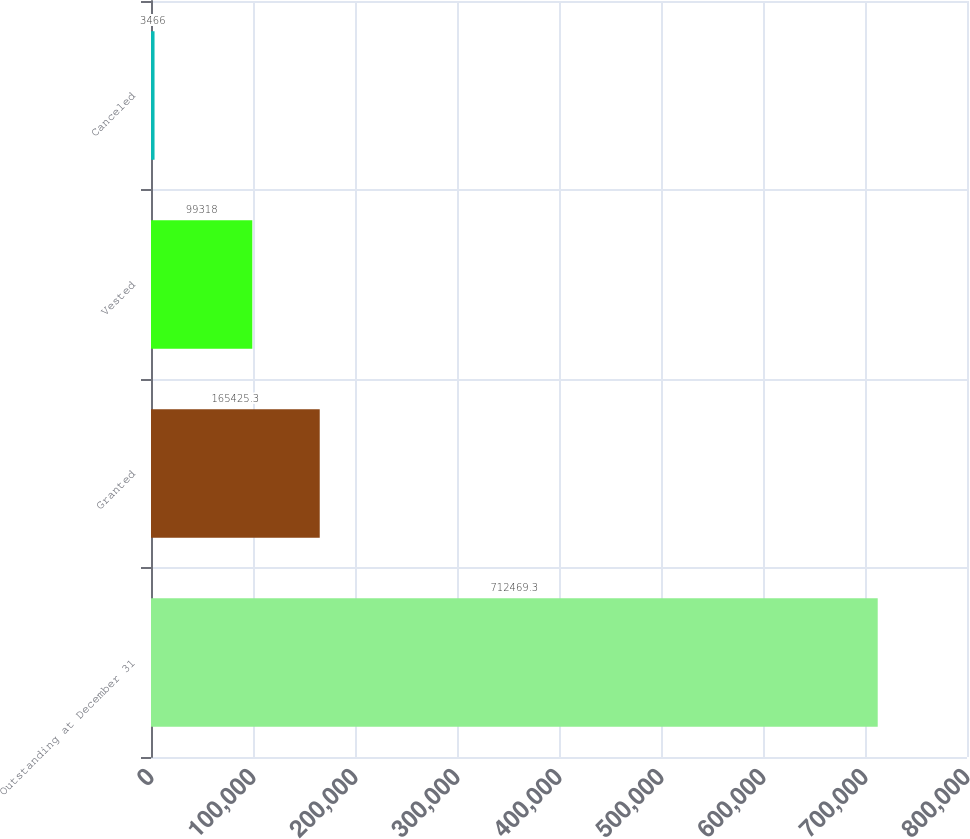Convert chart to OTSL. <chart><loc_0><loc_0><loc_500><loc_500><bar_chart><fcel>Outstanding at December 31<fcel>Granted<fcel>Vested<fcel>Canceled<nl><fcel>712469<fcel>165425<fcel>99318<fcel>3466<nl></chart> 